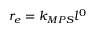Convert formula to latex. <formula><loc_0><loc_0><loc_500><loc_500>r _ { e } = k _ { M P S } l ^ { 0 }</formula> 